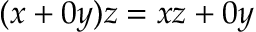<formula> <loc_0><loc_0><loc_500><loc_500>( x + 0 y ) z = x z + 0 y</formula> 